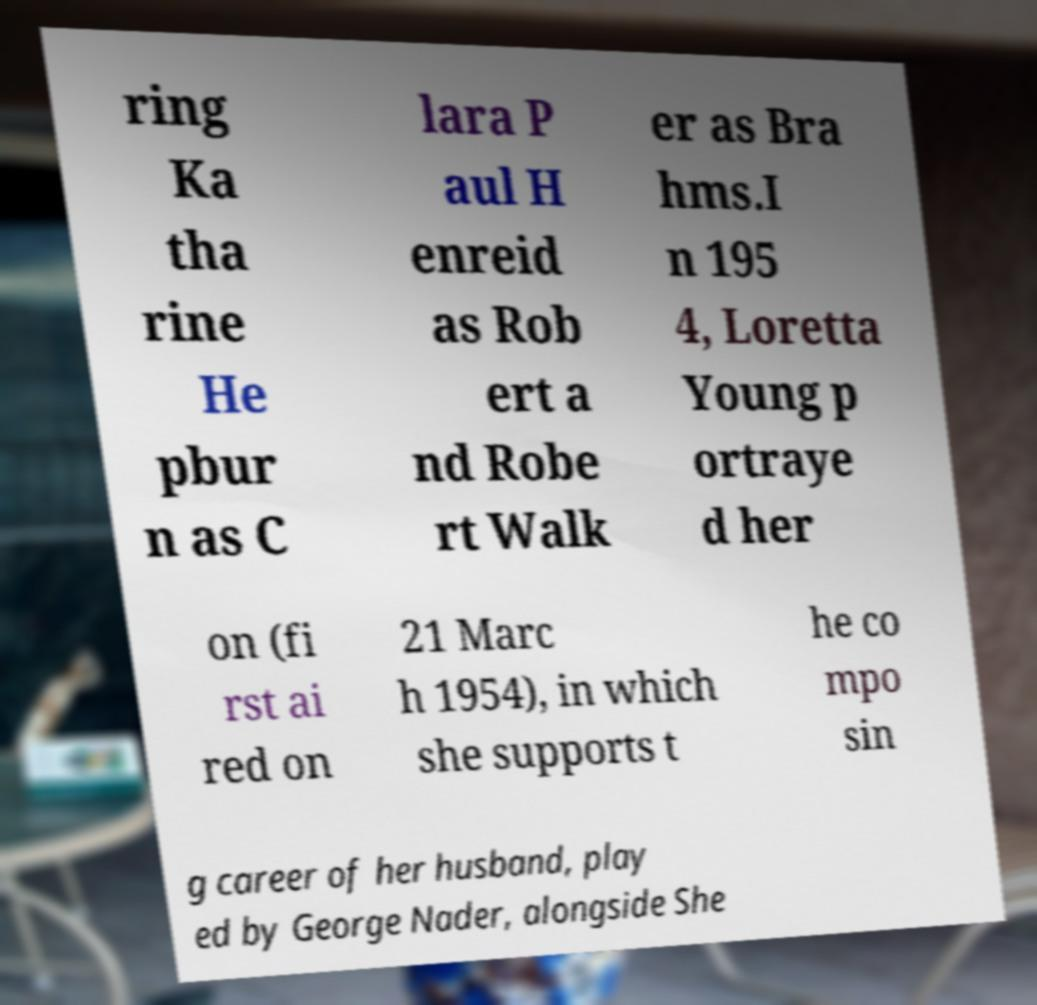Could you assist in decoding the text presented in this image and type it out clearly? ring Ka tha rine He pbur n as C lara P aul H enreid as Rob ert a nd Robe rt Walk er as Bra hms.I n 195 4, Loretta Young p ortraye d her on (fi rst ai red on 21 Marc h 1954), in which she supports t he co mpo sin g career of her husband, play ed by George Nader, alongside She 